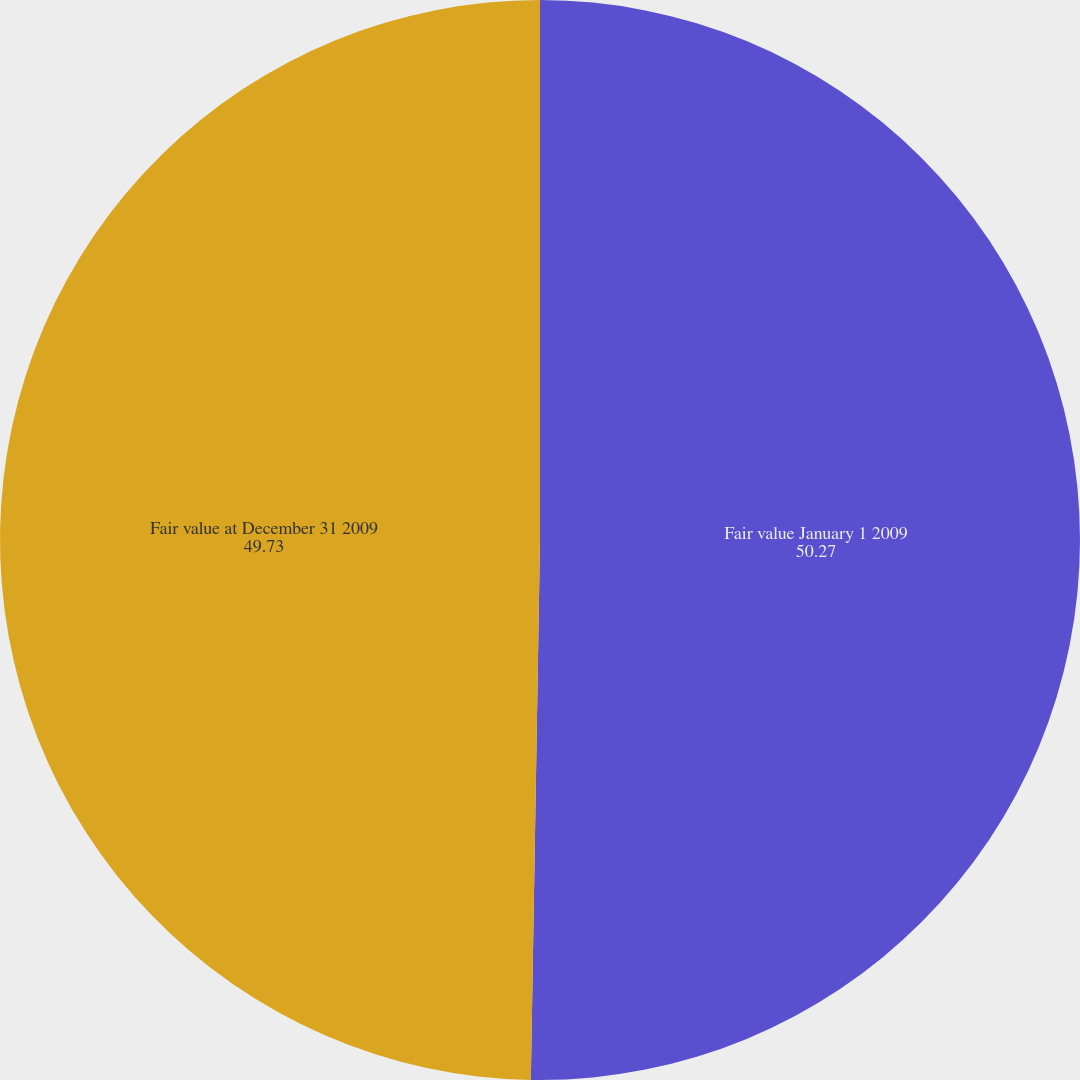Convert chart to OTSL. <chart><loc_0><loc_0><loc_500><loc_500><pie_chart><fcel>Fair value January 1 2009<fcel>Fair value at December 31 2009<nl><fcel>50.27%<fcel>49.73%<nl></chart> 